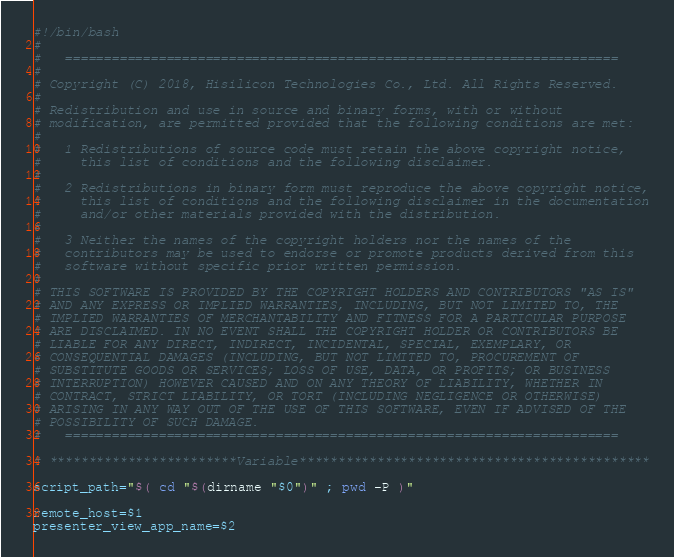<code> <loc_0><loc_0><loc_500><loc_500><_Bash_>#!/bin/bash
#
#   =======================================================================
#
# Copyright (C) 2018, Hisilicon Technologies Co., Ltd. All Rights Reserved.
#
# Redistribution and use in source and binary forms, with or without
# modification, are permitted provided that the following conditions are met:
#
#   1 Redistributions of source code must retain the above copyright notice,
#     this list of conditions and the following disclaimer.
#
#   2 Redistributions in binary form must reproduce the above copyright notice,
#     this list of conditions and the following disclaimer in the documentation
#     and/or other materials provided with the distribution.
#
#   3 Neither the names of the copyright holders nor the names of the
#   contributors may be used to endorse or promote products derived from this
#   software without specific prior written permission.
#
# THIS SOFTWARE IS PROVIDED BY THE COPYRIGHT HOLDERS AND CONTRIBUTORS "AS IS"
# AND ANY EXPRESS OR IMPLIED WARRANTIES, INCLUDING, BUT NOT LIMITED TO, THE
# IMPLIED WARRANTIES OF MERCHANTABILITY AND FITNESS FOR A PARTICULAR PURPOSE
# ARE DISCLAIMED. IN NO EVENT SHALL THE COPYRIGHT HOLDER OR CONTRIBUTORS BE
# LIABLE FOR ANY DIRECT, INDIRECT, INCIDENTAL, SPECIAL, EXEMPLARY, OR
# CONSEQUENTIAL DAMAGES (INCLUDING, BUT NOT LIMITED TO, PROCUREMENT OF
# SUBSTITUTE GOODS OR SERVICES; LOSS OF USE, DATA, OR PROFITS; OR BUSINESS
# INTERRUPTION) HOWEVER CAUSED AND ON ANY THEORY OF LIABILITY, WHETHER IN
# CONTRACT, STRICT LIABILITY, OR TORT (INCLUDING NEGLIGENCE OR OTHERWISE)
# ARISING IN ANY WAY OUT OF THE USE OF THIS SOFTWARE, EVEN IF ADVISED OF THE
# POSSIBILITY OF SUCH DAMAGE.
#   =======================================================================

# ************************Variable*********************************************

script_path="$( cd "$(dirname "$0")" ; pwd -P )"

remote_host=$1
presenter_view_app_name=$2</code> 